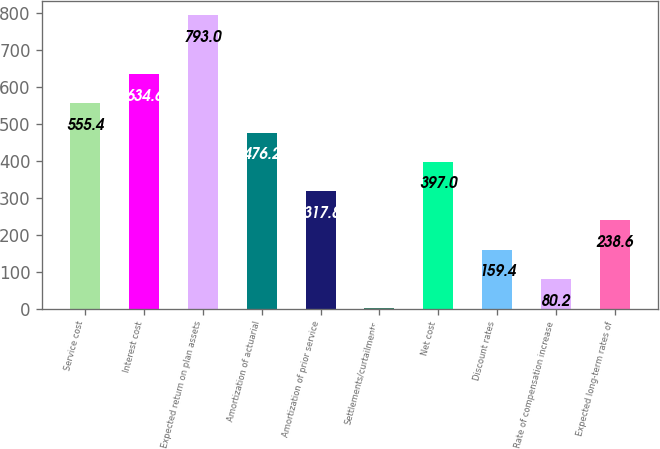Convert chart. <chart><loc_0><loc_0><loc_500><loc_500><bar_chart><fcel>Service cost<fcel>Interest cost<fcel>Expected return on plan assets<fcel>Amortization of actuarial<fcel>Amortization of prior service<fcel>Settlements/curtailments<fcel>Net cost<fcel>Discount rates<fcel>Rate of compensation increase<fcel>Expected long-term rates of<nl><fcel>555.4<fcel>634.6<fcel>793<fcel>476.2<fcel>317.8<fcel>1<fcel>397<fcel>159.4<fcel>80.2<fcel>238.6<nl></chart> 